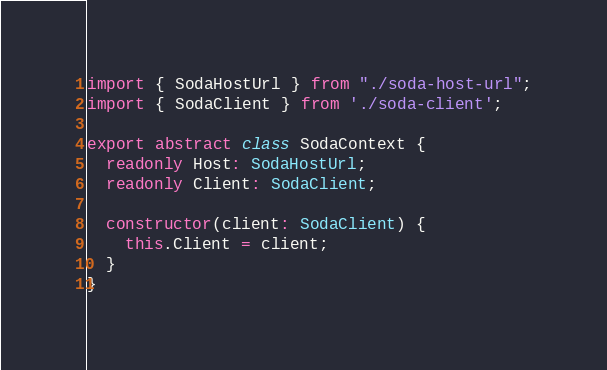Convert code to text. <code><loc_0><loc_0><loc_500><loc_500><_TypeScript_>import { SodaHostUrl } from "./soda-host-url";
import { SodaClient } from './soda-client';

export abstract class SodaContext {
  readonly Host: SodaHostUrl;
  readonly Client: SodaClient;

  constructor(client: SodaClient) {
    this.Client = client;
  }
}
</code> 